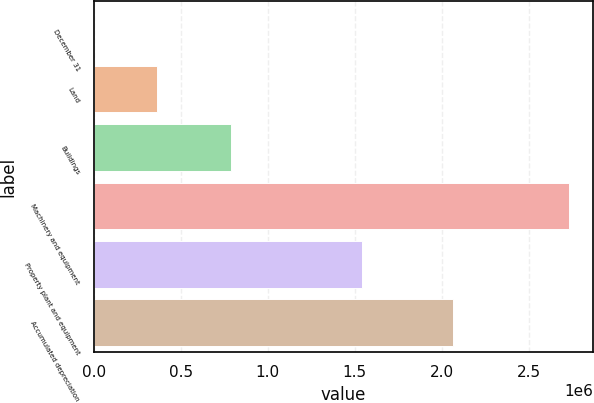<chart> <loc_0><loc_0><loc_500><loc_500><bar_chart><fcel>December 31<fcel>Land<fcel>Buildings<fcel>Machinery and equipment<fcel>Property plant and equipment<fcel>Accumulated depreciation<nl><fcel>2007<fcel>362451<fcel>788267<fcel>2.73158e+06<fcel>1.53972e+06<fcel>2.06673e+06<nl></chart> 